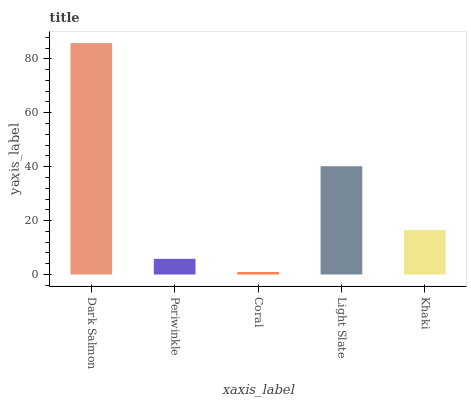Is Periwinkle the minimum?
Answer yes or no. No. Is Periwinkle the maximum?
Answer yes or no. No. Is Dark Salmon greater than Periwinkle?
Answer yes or no. Yes. Is Periwinkle less than Dark Salmon?
Answer yes or no. Yes. Is Periwinkle greater than Dark Salmon?
Answer yes or no. No. Is Dark Salmon less than Periwinkle?
Answer yes or no. No. Is Khaki the high median?
Answer yes or no. Yes. Is Khaki the low median?
Answer yes or no. Yes. Is Periwinkle the high median?
Answer yes or no. No. Is Light Slate the low median?
Answer yes or no. No. 